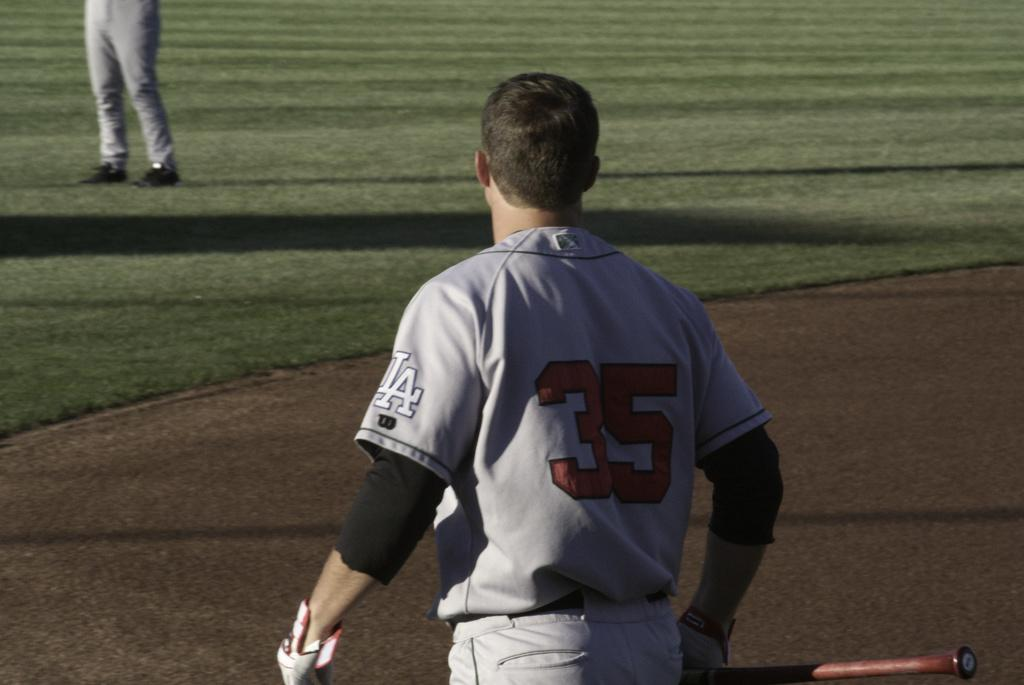<image>
Share a concise interpretation of the image provided. An LA baseball player with 35 on the back of his jersey. 